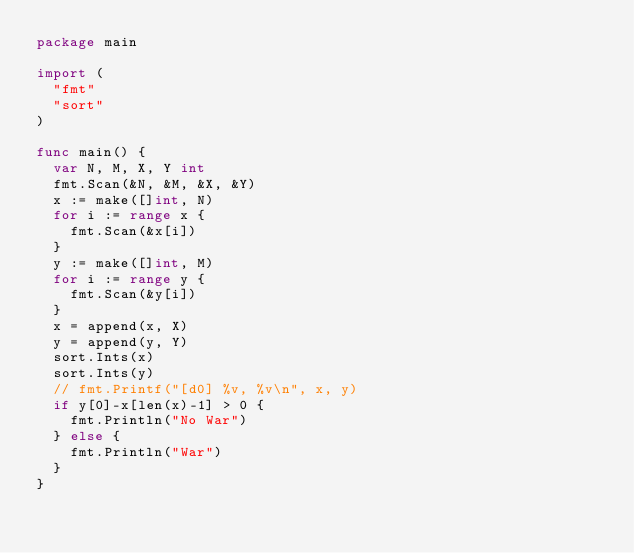<code> <loc_0><loc_0><loc_500><loc_500><_Go_>package main

import (
	"fmt"
	"sort"
)

func main() {
	var N, M, X, Y int
	fmt.Scan(&N, &M, &X, &Y)
	x := make([]int, N)
	for i := range x {
		fmt.Scan(&x[i])
	}
	y := make([]int, M)
	for i := range y {
		fmt.Scan(&y[i])
	}
	x = append(x, X)
	y = append(y, Y)
	sort.Ints(x)
	sort.Ints(y)
	// fmt.Printf("[d0] %v, %v\n", x, y)
	if y[0]-x[len(x)-1] > 0 {
		fmt.Println("No War")
	} else {
		fmt.Println("War")
	}
}
</code> 